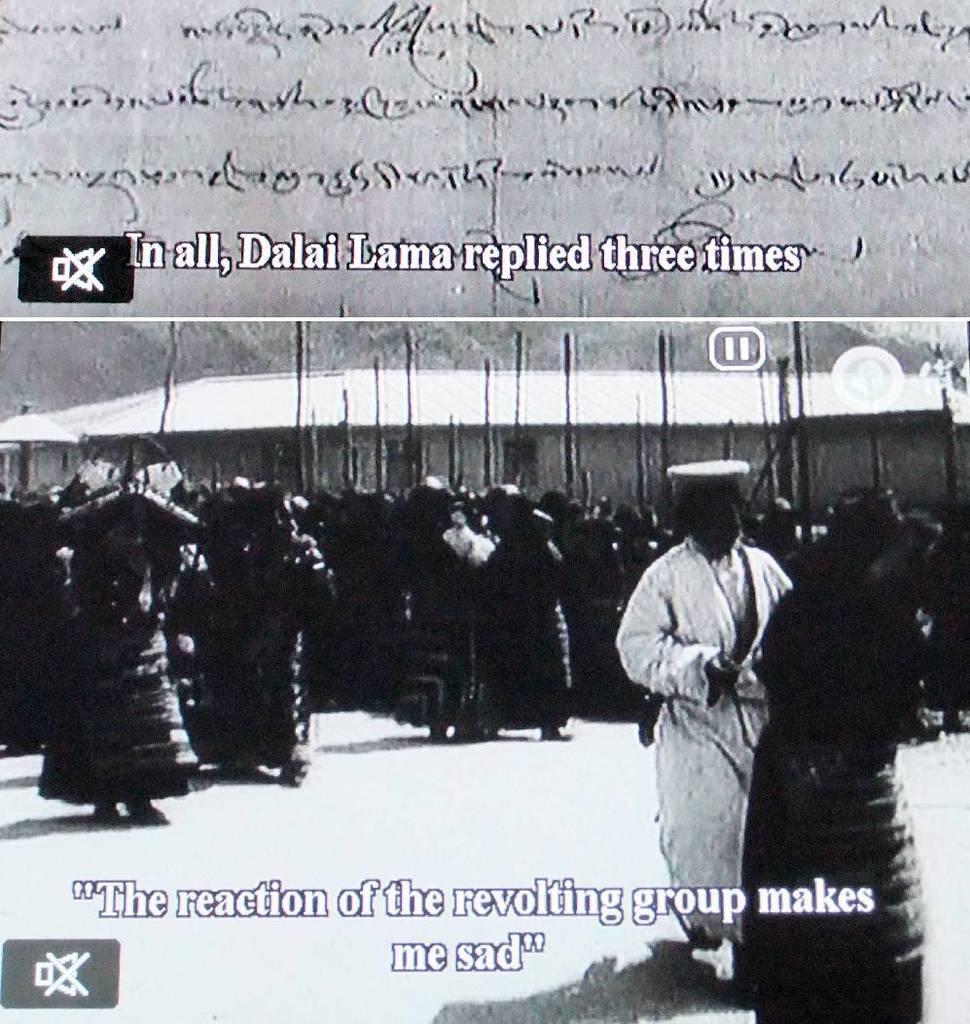How would you summarize this image in a sentence or two? In this image we can see a collage of a picture in which group of persons are standing. One person wearing white dress is holding a stick in his hand. 